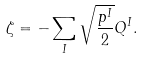<formula> <loc_0><loc_0><loc_500><loc_500>\zeta = - \sum _ { I } \sqrt { \frac { p ^ { I } } { 2 } } Q ^ { I } .</formula> 